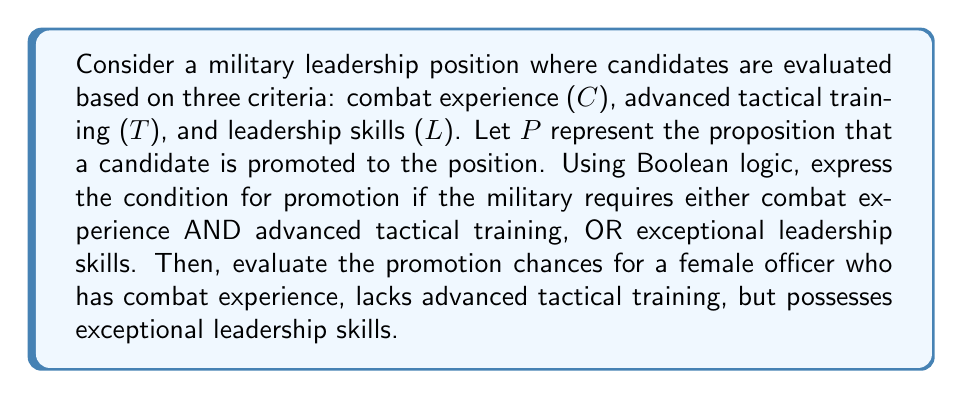Give your solution to this math problem. Let's approach this step-by-step:

1) First, we need to express the promotion condition using Boolean logic:
   $P = (C \land T) \lor L$

   Where:
   $\land$ represents AND
   $\lor$ represents OR

2) Now, let's evaluate the case for the female officer:
   C = 1 (has combat experience)
   T = 0 (lacks advanced tactical training)
   L = 1 (possesses exceptional leadership skills)

3) Let's substitute these values into our Boolean expression:

   $P = (C \land T) \lor L$
   $P = (1 \land 0) \lor 1$

4) Evaluate the AND operation first:
   $1 \land 0 = 0$

   So our expression becomes:
   $P = 0 \lor 1$

5) Now evaluate the OR operation:
   $0 \lor 1 = 1$

6) Therefore, P = 1, which means the proposition is true.

This indicates that the female officer would be promoted based on her exceptional leadership skills, despite lacking advanced tactical training.
Answer: $P = 1$ (True) 